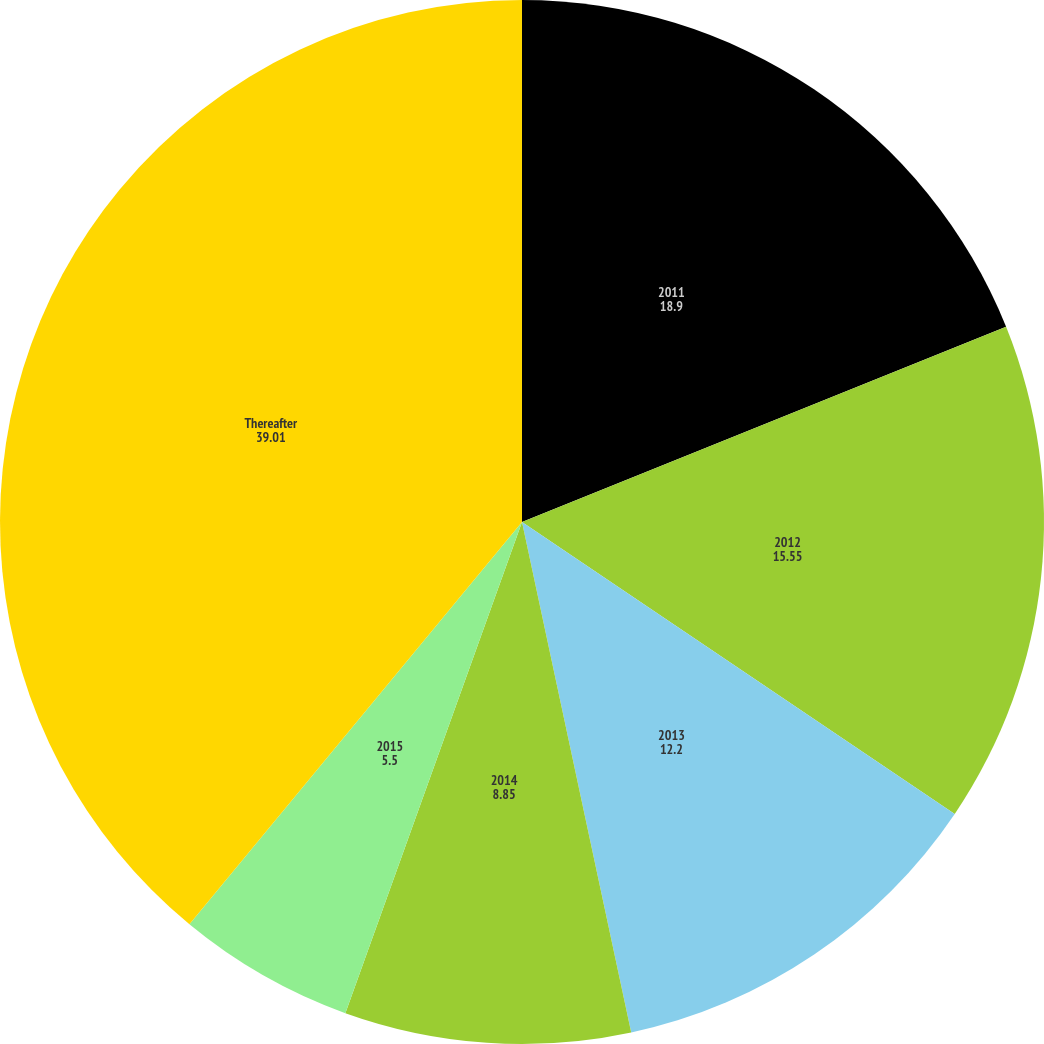Convert chart. <chart><loc_0><loc_0><loc_500><loc_500><pie_chart><fcel>2011<fcel>2012<fcel>2013<fcel>2014<fcel>2015<fcel>Thereafter<nl><fcel>18.9%<fcel>15.55%<fcel>12.2%<fcel>8.85%<fcel>5.5%<fcel>39.01%<nl></chart> 